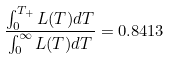Convert formula to latex. <formula><loc_0><loc_0><loc_500><loc_500>\frac { \int _ { 0 } ^ { T _ { + } } { L ( T ) d T } } { \int _ { 0 } ^ { \infty } { L ( T ) d T } } = 0 . 8 4 1 3</formula> 